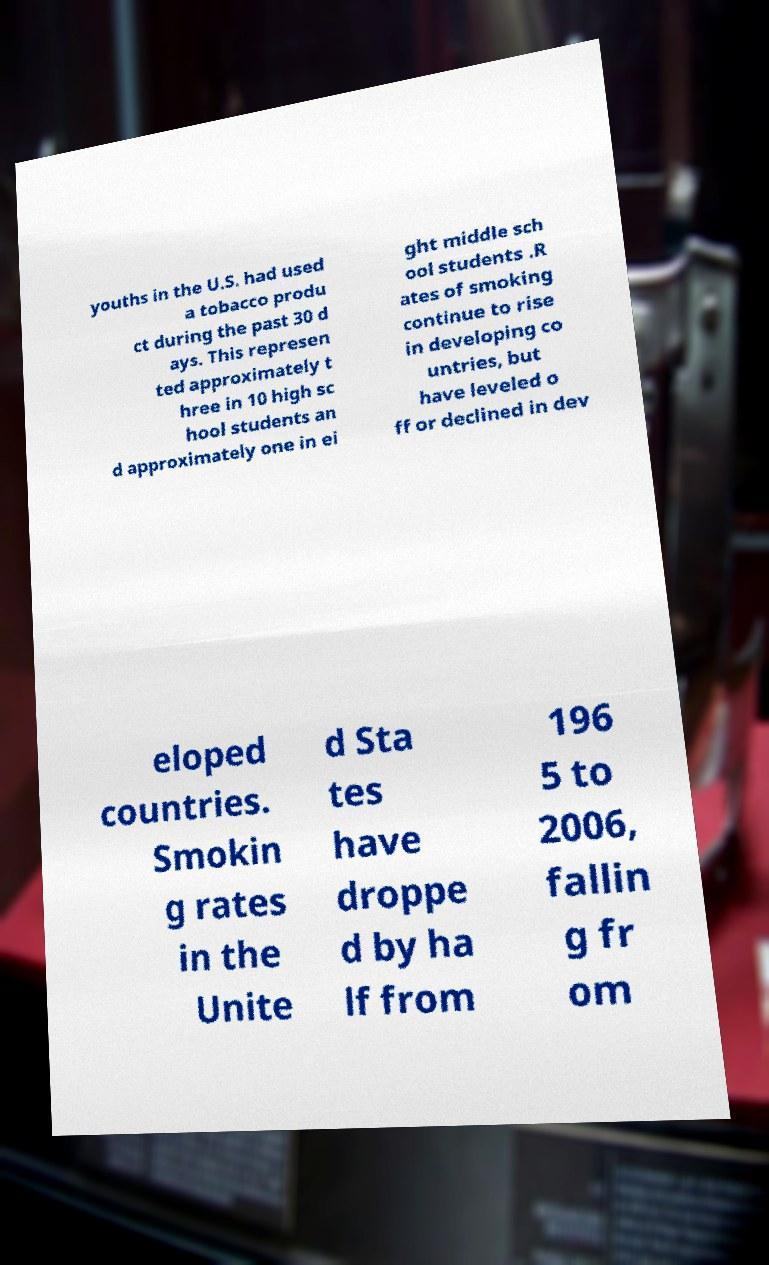For documentation purposes, I need the text within this image transcribed. Could you provide that? youths in the U.S. had used a tobacco produ ct during the past 30 d ays. This represen ted approximately t hree in 10 high sc hool students an d approximately one in ei ght middle sch ool students .R ates of smoking continue to rise in developing co untries, but have leveled o ff or declined in dev eloped countries. Smokin g rates in the Unite d Sta tes have droppe d by ha lf from 196 5 to 2006, fallin g fr om 